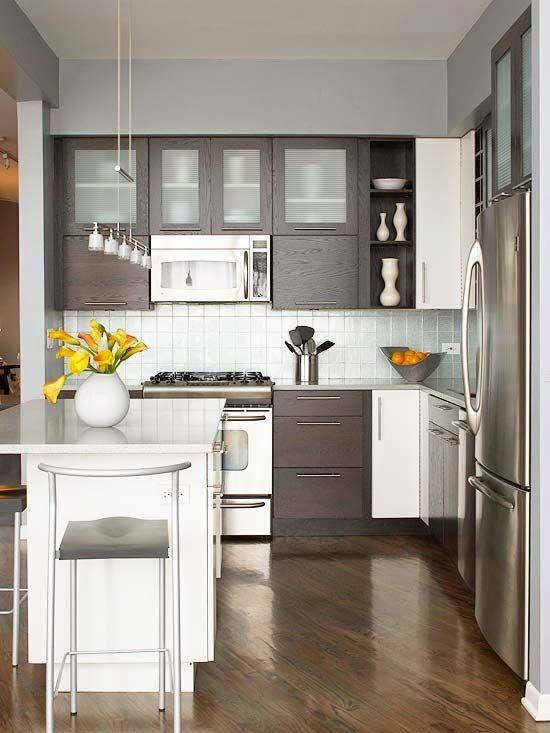Considering the design and items within this kitchen, what can be inferred about the resident's preference for kitchen functionality and aesthetic? The design and setup of the kitchen suggest that the resident favors a minimalist and contemporary style, emphasizing functionality combined with a visually appealing modern aesthetic. The choice of muted grey and white tones gives the space an airy and open feel, while the dark wood provides a warm contrast, exuding an inviting atmosphere. Essential appliances like the stainless steel refrigerator and gas stove indicate a utilitarian approach to kitchen functionality, aimed at efficiency and durability. The use of space is thoughtful, with a compact island serving as both a cooking prep area and a casual dining space, likely reflecting the resident's preference for streamlined, multipurpose furnishings. This kitchen is evidently designed for someone who appreciates clean lines, neutral colors, and a tidy environment, with just enough personalized touches, such as the fresh flowers, to offer a homely feel. 